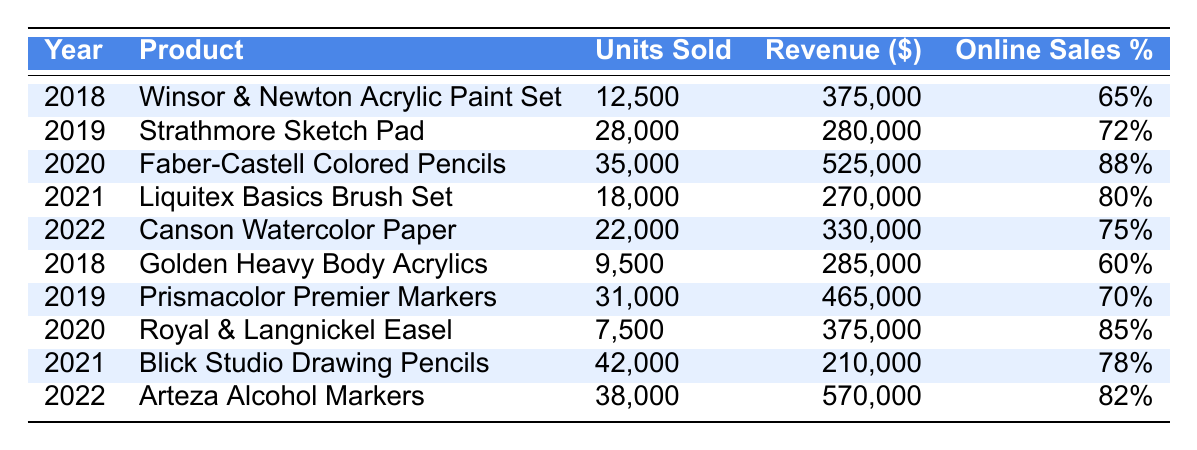What was the total revenue generated from the Faber-Castell Colored Pencils? According to the table, the revenue generated from the Faber-Castell Colored Pencils in 2020 is $525,000. This value can be directly retrieved from the corresponding row for this product.
Answer: $525,000 Which product had the highest units sold in 2021? In the year 2021, the products listed are Liquitex Basics Brush Set and Blick Studio Drawing Pencils. The Liquitex Basics Brush Set had 18,000 units sold, while Blick Studio Drawing Pencils had 42,000 units sold. Therefore, Blick Studio Drawing Pencils had the highest units sold.
Answer: Blick Studio Drawing Pencils What is the average online sales percentage for all products listed? The online sales percentages are 65, 72, 88, 80, 75, 60, 70, 85, 78, and 82. We can sum these values: 65 + 72 + 88 + 80 + 75 + 60 + 70 + 85 + 78 + 82 = 790. There are 10 products, so the average is 790 / 10 = 79.
Answer: 79 Did any product have an online sales percentage above 80%? Looking through the online sales percentages listed in the table, we can observe that the Faber-Castell Colored Pencils, Royal & Langnickel Easel, and Arteza Alcohol Markers all have percentages above 80%, confirming that there are products with online sales percentages above this threshold.
Answer: Yes What was the difference in units sold between the product with the highest revenue and the product with the lowest revenue in 2019? In 2019, the Strathmore Sketch Pad had the highest revenue of $280,000 with 28,000 units sold, while the Prismacolor Premier Markers had a higher revenue of $465,000, selling 31,000 units. Therefore, calculating the difference in units sold: 31,000 - 28,000 = 3,000 units.
Answer: 3,000 units What was the trend in revenue from 2018 to 2022 for products with over 35,000 units sold? From 2018 to 2022, the only product with over 35,000 units sold is Faber-Castell Colored Pencils (2020) with a revenue of 525,000 and Arteza Alcohol Markers (2022) with a revenue of 570,000. This shows an increase in revenue over these years for products sold in higher quantities, indicating a positive trend.
Answer: Positive trend What percentage of total revenue in 2022 came from units sold of the Canson Watercolor Paper? In 2022, the revenue from Canson Watercolor Paper is $330,000. The total revenue for 2022 (Arteza Alcohol Markers + Canson Watercolor Paper) is $570,000 + $330,000 = $900,000. To find the percentage from Canson Watercolor Paper, we use the formula (330,000 / 900,000) * 100 = 36.67%.
Answer: 36.67% 